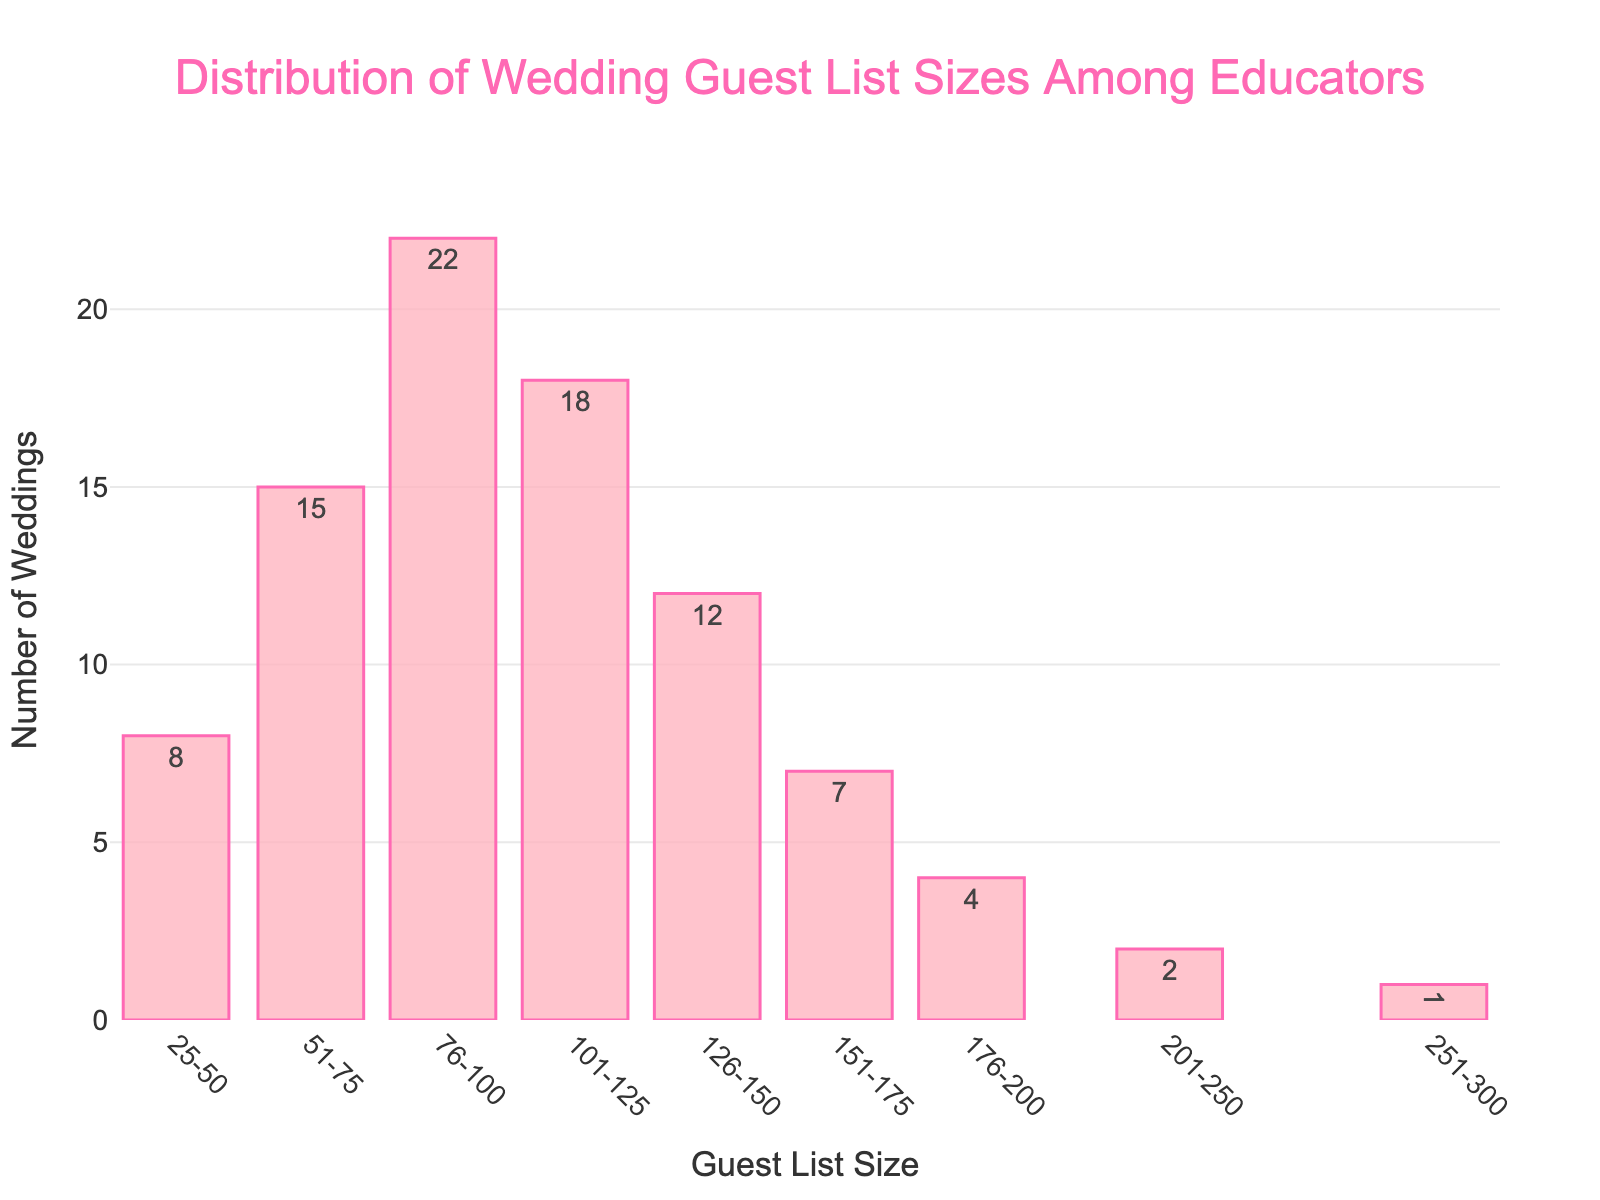what's the title of the figure? The title of the figure is usually displayed at the top and often summarizes the content. In this case, the title states the topic.
Answer: Distribution of Wedding Guest List Sizes Among Educators what is the range with the highest number of weddings? To find this, look for the tallest bar in the histogram.
Answer: 76-100 how many weddings had guest list sizes between 101-125? Check the height of the bar labeled 101-125.
Answer: 18 how many weddings had guest lists larger than 175? Sum the numbers above 175: 4 (176-200) + 2 (201-250) + 1 (251-300).
Answer: 7 which guest list range is the least common? Look for the shortest bar in the histogram.
Answer: 251-300 what's the total number of weddings shown in the figure? Sum all the values of the Number_of_Weddings column: 8+15+22+18+12+7+4+2+1.
Answer: 89 what is the average number of weddings in each guest list size range? Calculate the total number of weddings (89) and divide it by the number of ranges (9).
Answer: 9.89 how does the number of weddings with guest lists between 76-100 compare to those between 151-175? Compare the heights of these two bars: 22 (76-100) vs. 7 (151-175).
Answer: 76-100 is 15 more than 151-175 which guest list size ranges have fewer than 10 weddings? Identify bars lower than 10: 25-50, 151-175, 176-200, 201-250, 251-300.
Answer: 25-50, 151-175, 176-200, 201-250, 251-300 